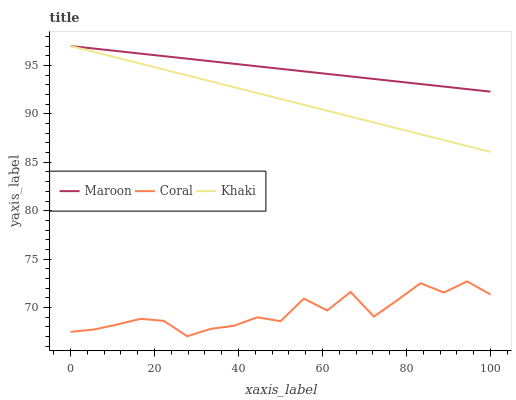Does Coral have the minimum area under the curve?
Answer yes or no. Yes. Does Maroon have the maximum area under the curve?
Answer yes or no. Yes. Does Khaki have the minimum area under the curve?
Answer yes or no. No. Does Khaki have the maximum area under the curve?
Answer yes or no. No. Is Khaki the smoothest?
Answer yes or no. Yes. Is Coral the roughest?
Answer yes or no. Yes. Is Maroon the smoothest?
Answer yes or no. No. Is Maroon the roughest?
Answer yes or no. No. Does Coral have the lowest value?
Answer yes or no. Yes. Does Khaki have the lowest value?
Answer yes or no. No. Does Maroon have the highest value?
Answer yes or no. Yes. Is Coral less than Khaki?
Answer yes or no. Yes. Is Khaki greater than Coral?
Answer yes or no. Yes. Does Khaki intersect Maroon?
Answer yes or no. Yes. Is Khaki less than Maroon?
Answer yes or no. No. Is Khaki greater than Maroon?
Answer yes or no. No. Does Coral intersect Khaki?
Answer yes or no. No. 